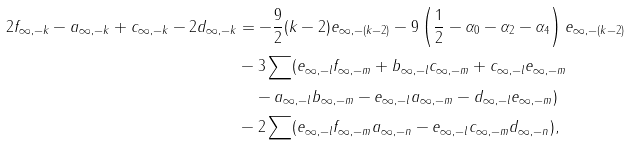Convert formula to latex. <formula><loc_0><loc_0><loc_500><loc_500>2 f _ { \infty , - k } - a _ { \infty , - k } + c _ { \infty , - k } - 2 d _ { \infty , - k } & = - \frac { 9 } { 2 } ( k - 2 ) e _ { \infty , - ( k - 2 ) } - 9 \left ( \frac { 1 } { 2 } - \alpha _ { 0 } - \alpha _ { 2 } - \alpha _ { 4 } \right ) e _ { \infty , - ( k - 2 ) } \\ & - 3 \sum ( e _ { \infty , - l } f _ { \infty , - m } + b _ { \infty , - l } c _ { \infty , - m } + c _ { \infty , - l } e _ { \infty , - m } \\ & \quad - a _ { \infty , - l } b _ { \infty , - m } - e _ { \infty , - l } a _ { \infty , - m } - d _ { \infty , - l } e _ { \infty , - m } ) \\ & - 2 \sum ( e _ { \infty , - l } f _ { \infty , - m } a _ { \infty , - n } - e _ { \infty , - l } c _ { \infty , - m } d _ { \infty , - n } ) ,</formula> 